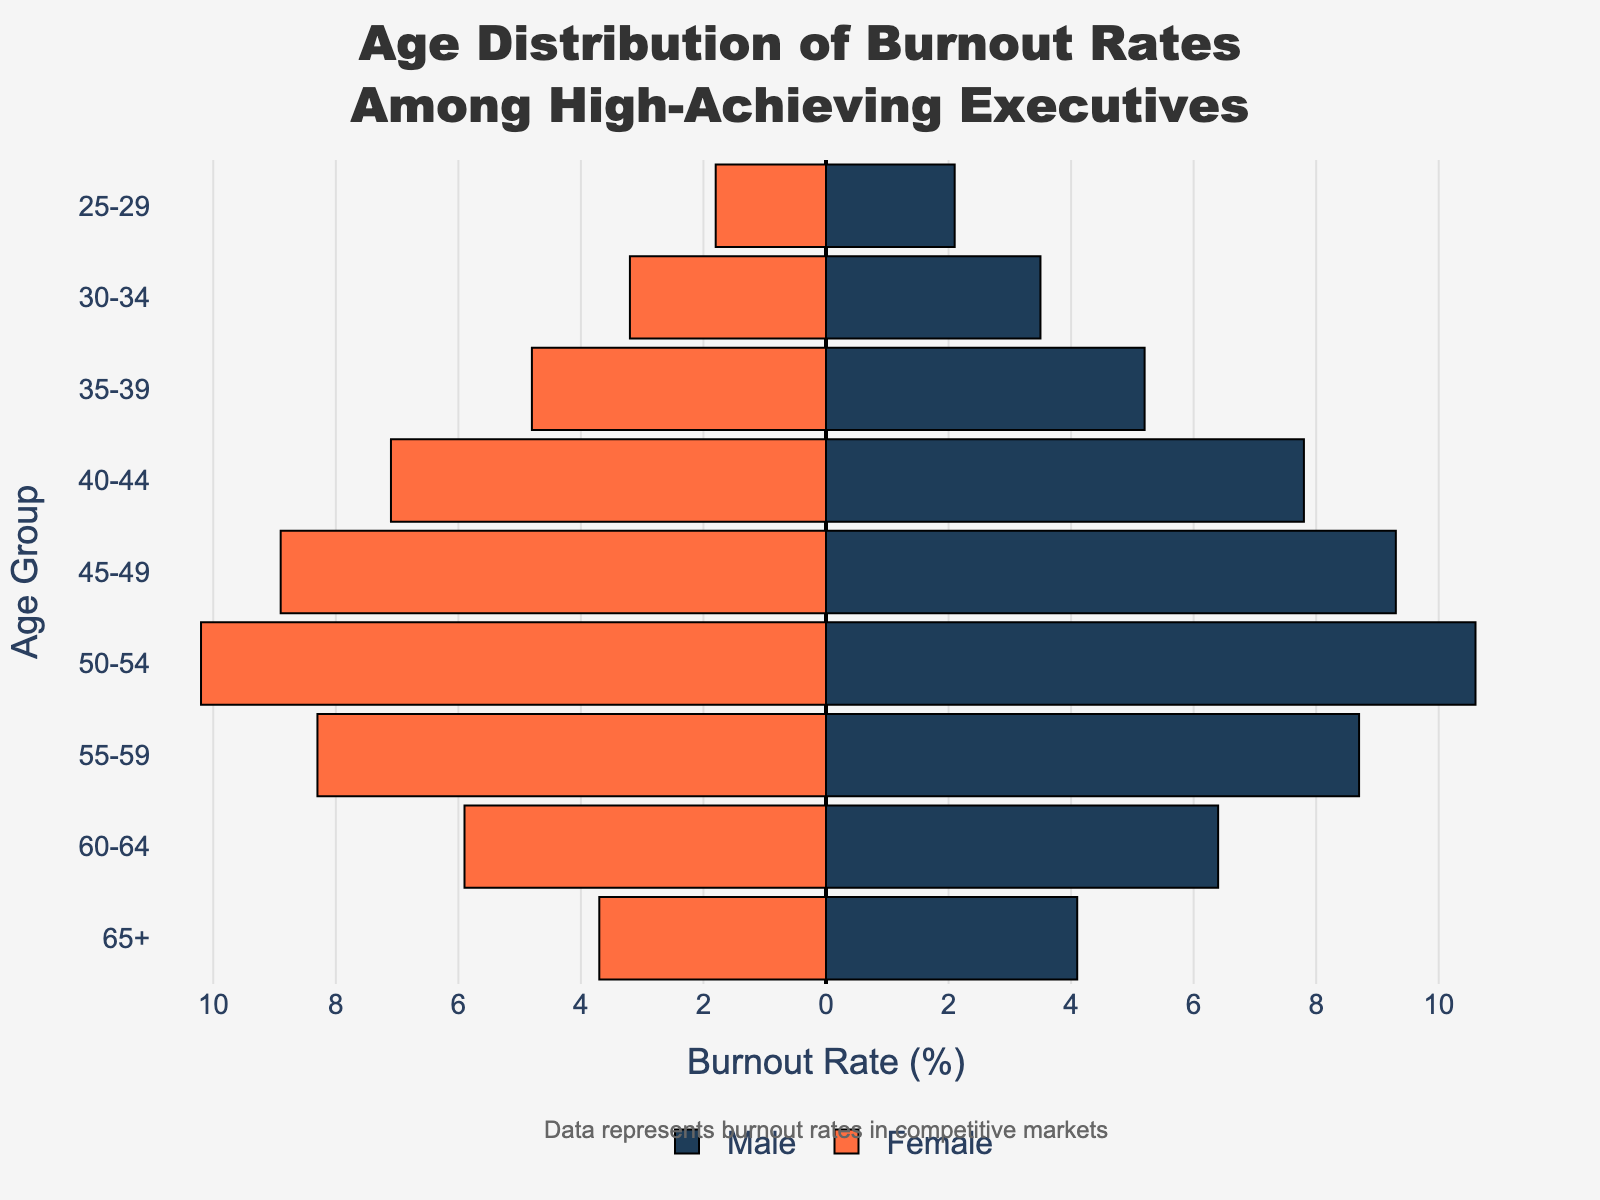What is the age group with the highest burnout rate for males? According to the left side of the pyramid where male burnout rates are represented, the age group 50-54 has the highest rate at 10.6%.
Answer: 50-54 Which age group has the smallest difference in burnout rates between males and females? By examining each age group, the 55-59 group has the smallest difference, with males at 8.7% and females at 8.3%, resulting in a difference of 0.4%.
Answer: 55-59 What is the overall trend in burnout rates for females as age increases? The female burnout rates increase steadily from 25-29 to 50-54, peak at 50-54, and then decrease through the remaining age groups.
Answer: Increase until 50-54, then decrease What is the total burnout rate for males and females in the 25-29 age group? The male burnout rate is 2.1% and the female burnout rate is 1.8%. Summing these gives a total of 3.9%.
Answer: 3.9% How does the burnout rate for females in the 40-44 age group compare to that of males in the same group? The female burnout rate in the 40-44 age group is 7.1%, while the male burnout rate is 7.8%. Therefore, females have a slightly lower burnout rate than males by 0.7%.
Answer: Lower by 0.7% What is the average burnout rate for males across all age groups? Sum the male rates (2.1 + 3.5 + 5.2 + 7.8 + 9.3 + 10.6 + 8.7 + 6.4 + 4.1) and divide by the number of groups (9). The sum is 57.7, so the average is 57.7 / 9 ≈ 6.41%.
Answer: 6.41% Which gender has a higher burnout rate in the 60-64 age group, and by how much? Females have a burnout rate of 5.9% in this age group, while males have 6.4%, making males higher by 0.5%.
Answer: Males by 0.5% How does the trend of burnout rates between males and females change from 30-34 to 65+ age groups? Both males and females follow a similar pattern: increase until 50-54, then decrease.
Answer: Similar pattern What is the highest burnout rate among all age groups and genders? The highest burnout rate is for males in the 50-54 age group at 10.6%.
Answer: 10.6% In which age group is the disparity between male and female burnout rates the largest? The largest disparity is in the 50-54 age group, where males have a burnout rate of 10.6% and females 10.2%, a difference of 0.4%.
Answer: 50-54 